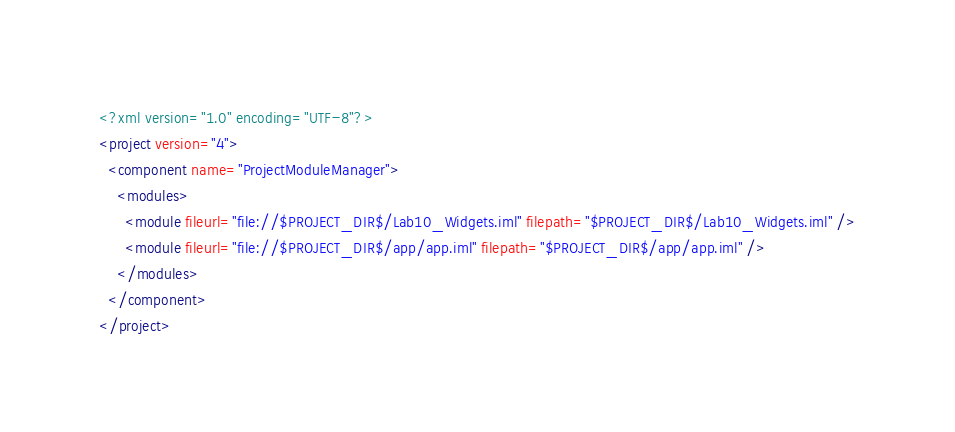Convert code to text. <code><loc_0><loc_0><loc_500><loc_500><_XML_><?xml version="1.0" encoding="UTF-8"?>
<project version="4">
  <component name="ProjectModuleManager">
    <modules>
      <module fileurl="file://$PROJECT_DIR$/Lab10_Widgets.iml" filepath="$PROJECT_DIR$/Lab10_Widgets.iml" />
      <module fileurl="file://$PROJECT_DIR$/app/app.iml" filepath="$PROJECT_DIR$/app/app.iml" />
    </modules>
  </component>
</project></code> 